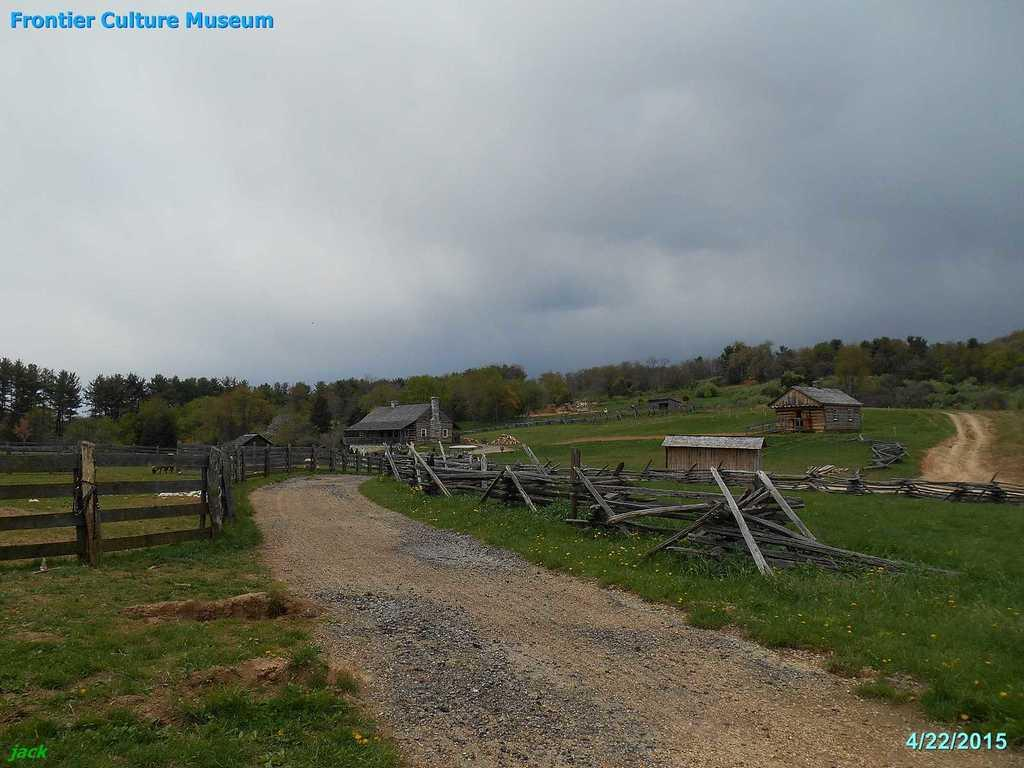What type of structures can be seen in the image? There are houses in the image. What type of vegetation is present in the image? There are trees in the image. What objects can be found on the ground in the image? There are wooden sticks and grass on the ground in the image. What is visible in the background of the image? The sky is visible in the background of the image. What can be observed in the sky in the image? Clouds are present in the sky. How far away is the frame of the image from the houses? There is no frame present in the image, as it is a photograph or digital representation of the scene. What type of cellar can be seen in the image? There is no cellar present in the image; it features houses, trees, wooden sticks, grass, and a sky with clouds. 